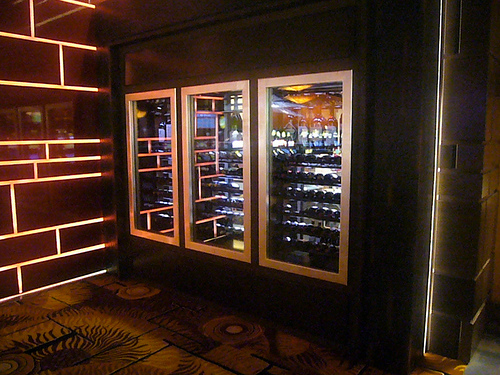<image>
Is the wine on the floor? No. The wine is not positioned on the floor. They may be near each other, but the wine is not supported by or resting on top of the floor. 